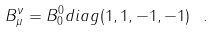Convert formula to latex. <formula><loc_0><loc_0><loc_500><loc_500>B ^ { \nu } _ { \mu } = B ^ { 0 } _ { 0 } d i a g ( 1 , 1 , - 1 , - 1 ) \ .</formula> 